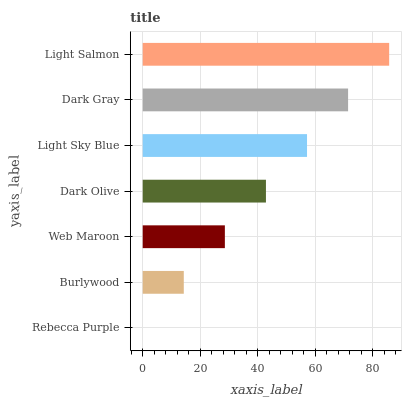Is Rebecca Purple the minimum?
Answer yes or no. Yes. Is Light Salmon the maximum?
Answer yes or no. Yes. Is Burlywood the minimum?
Answer yes or no. No. Is Burlywood the maximum?
Answer yes or no. No. Is Burlywood greater than Rebecca Purple?
Answer yes or no. Yes. Is Rebecca Purple less than Burlywood?
Answer yes or no. Yes. Is Rebecca Purple greater than Burlywood?
Answer yes or no. No. Is Burlywood less than Rebecca Purple?
Answer yes or no. No. Is Dark Olive the high median?
Answer yes or no. Yes. Is Dark Olive the low median?
Answer yes or no. Yes. Is Web Maroon the high median?
Answer yes or no. No. Is Dark Gray the low median?
Answer yes or no. No. 